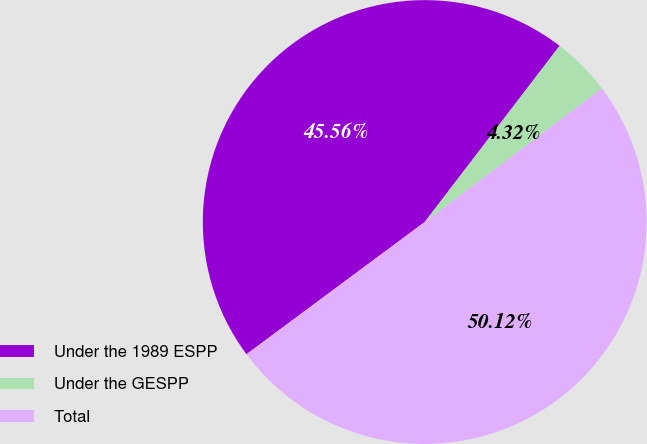Convert chart. <chart><loc_0><loc_0><loc_500><loc_500><pie_chart><fcel>Under the 1989 ESPP<fcel>Under the GESPP<fcel>Total<nl><fcel>45.56%<fcel>4.32%<fcel>50.12%<nl></chart> 